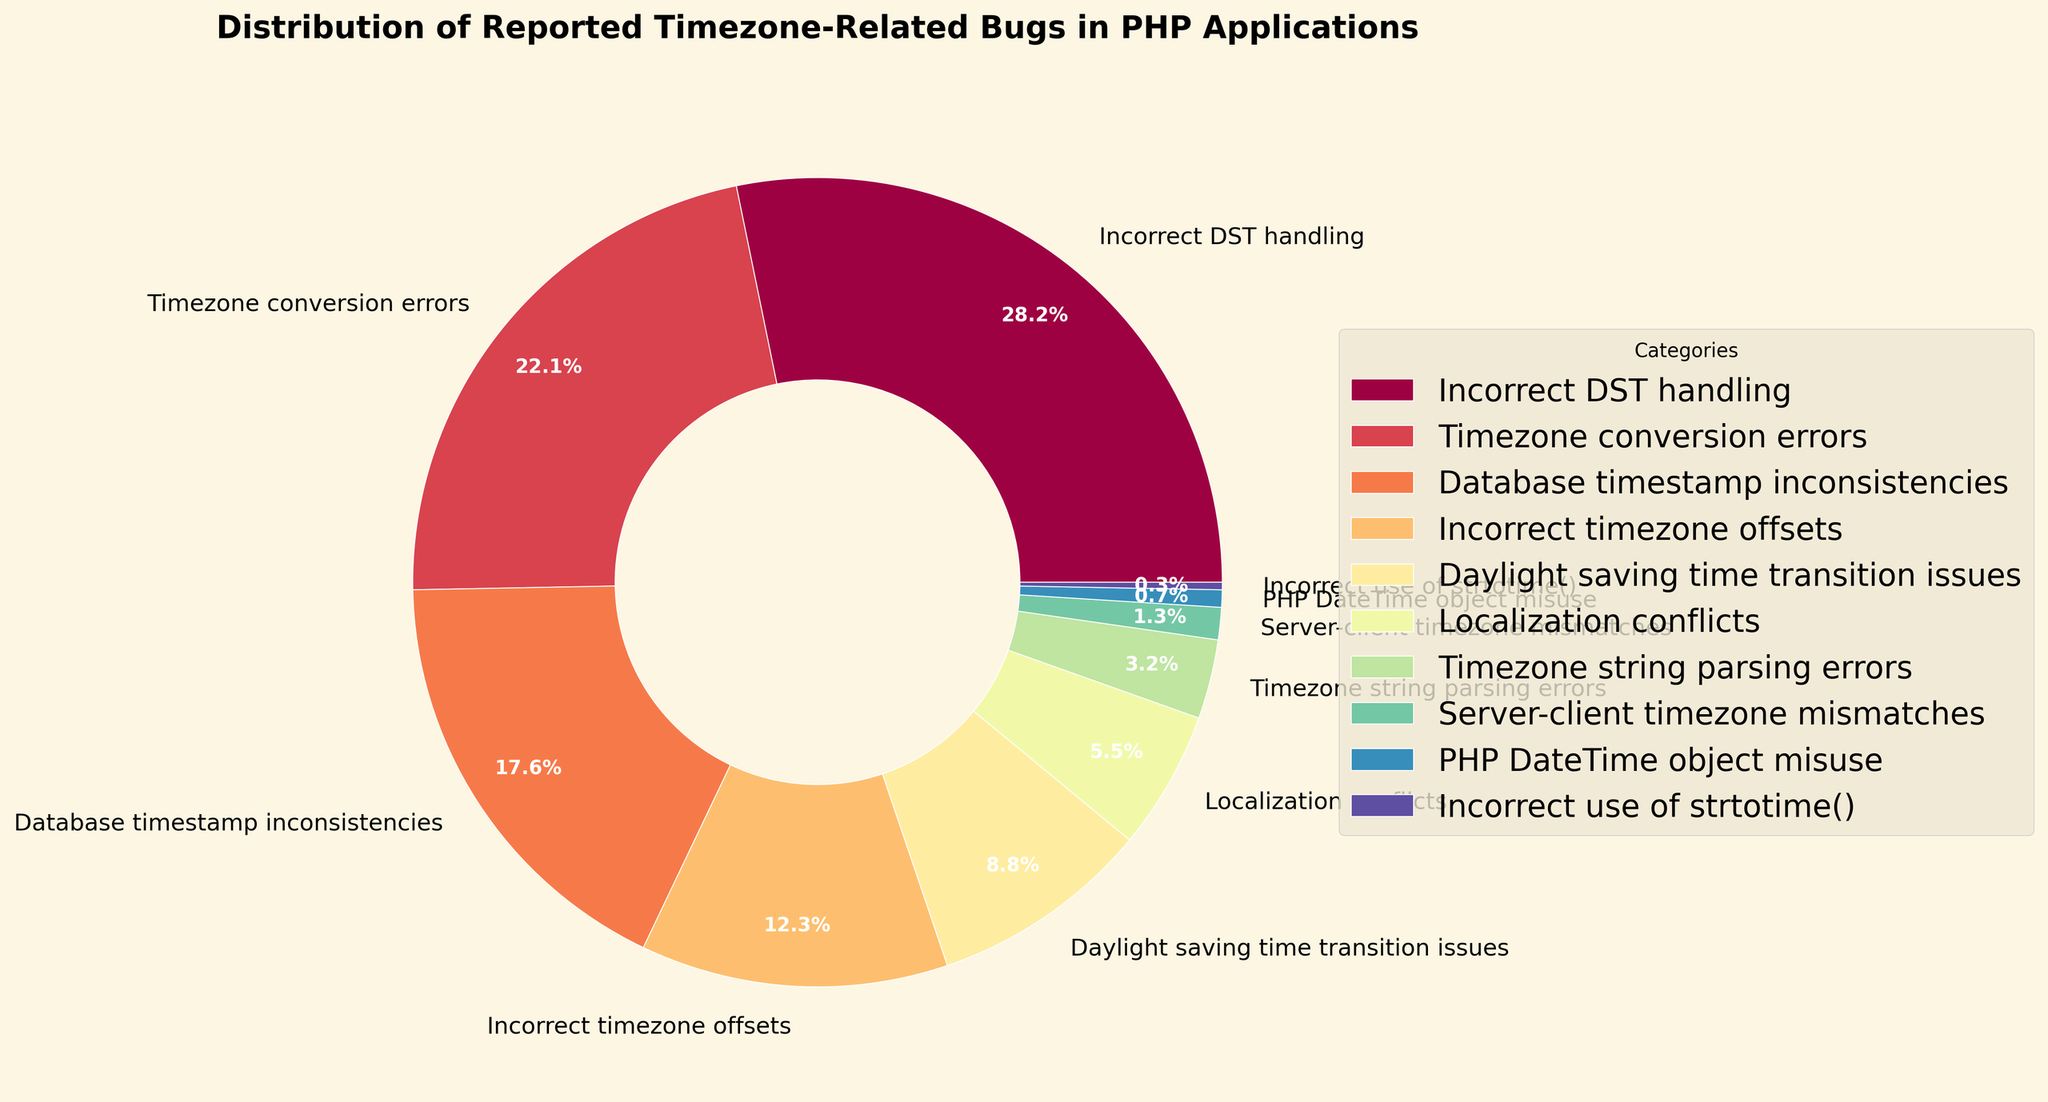Which category has the highest percentage of reported bugs? First, identify the category with the highest percentage by looking at the segments of the pie chart. The largest segment of the pie chart represents "Incorrect DST handling" at 28.5%.
Answer: Incorrect DST handling Which issue accounts for only 0.3% of the reported bugs? Locate the smallest segment on the pie chart, which is labeled. This segment represents "Incorrect use of strtotime()" with a percentage of 0.3%.
Answer: Incorrect use of strtotime() What is the total percentage of bugs related to Daylight Saving Time (DST) handling, including incorrect handling and transition issues? First, find the percentage for "Incorrect DST handling" (28.5%) and "Daylight saving time transition issues" (8.9%). Then sum these two values: 28.5% + 8.9% = 37.4%.
Answer: 37.4% Are Database timestamp inconsistencies more frequently reported than Timezone conversion errors? Compare the percentages of "Database timestamp inconsistencies" (17.8%) and "Timezone conversion errors" (22.3%). Since 17.8% is less than 22.3%, Database timestamp inconsistencies are less frequently reported.
Answer: No How many categories account for less than 5% of the reported bugs? Identify the segments of the pie chart with percentages less than 5%. There are three categories: "Localization conflicts" (5.6%), "Timezone string parsing errors" (3.2%), "Server-client timezone mismatches" (1.3%), "PHP DateTime object misuse" (0.7%), and "Incorrect use of strtotime()" (0.3%). Therefore, there are 5 categories.
Answer: 5 What is the combined percentage of the three least frequent bug categories? Identify the three smallest segments: "Incorrect use of strtotime()" (0.3%), "PHP DateTime object misuse" (0.7%), and "Server-client timezone mismatches" (1.3%). Sum these values: 0.3% + 0.7% + 1.3% = 2.3%.
Answer: 2.3% Which category appears in orange color? Identify the segment colored in orange. The segment representing "Daylight saving time transition issues" appears in orange.
Answer: Daylight saving time transition issues Is the percentage of Timezone conversion errors closer to Localization conflicts or Incorrect timezone offsets? Compare the percentage of "Timezone conversion errors" (22.3%) with "Localization conflicts" (5.6%) and "Incorrect timezone offsets" (12.4%). The percentage of "Timezone conversion errors" is closer to "Incorrect timezone offsets" (22.3% vs. 12.4%).
Answer: Incorrect timezone offsets 